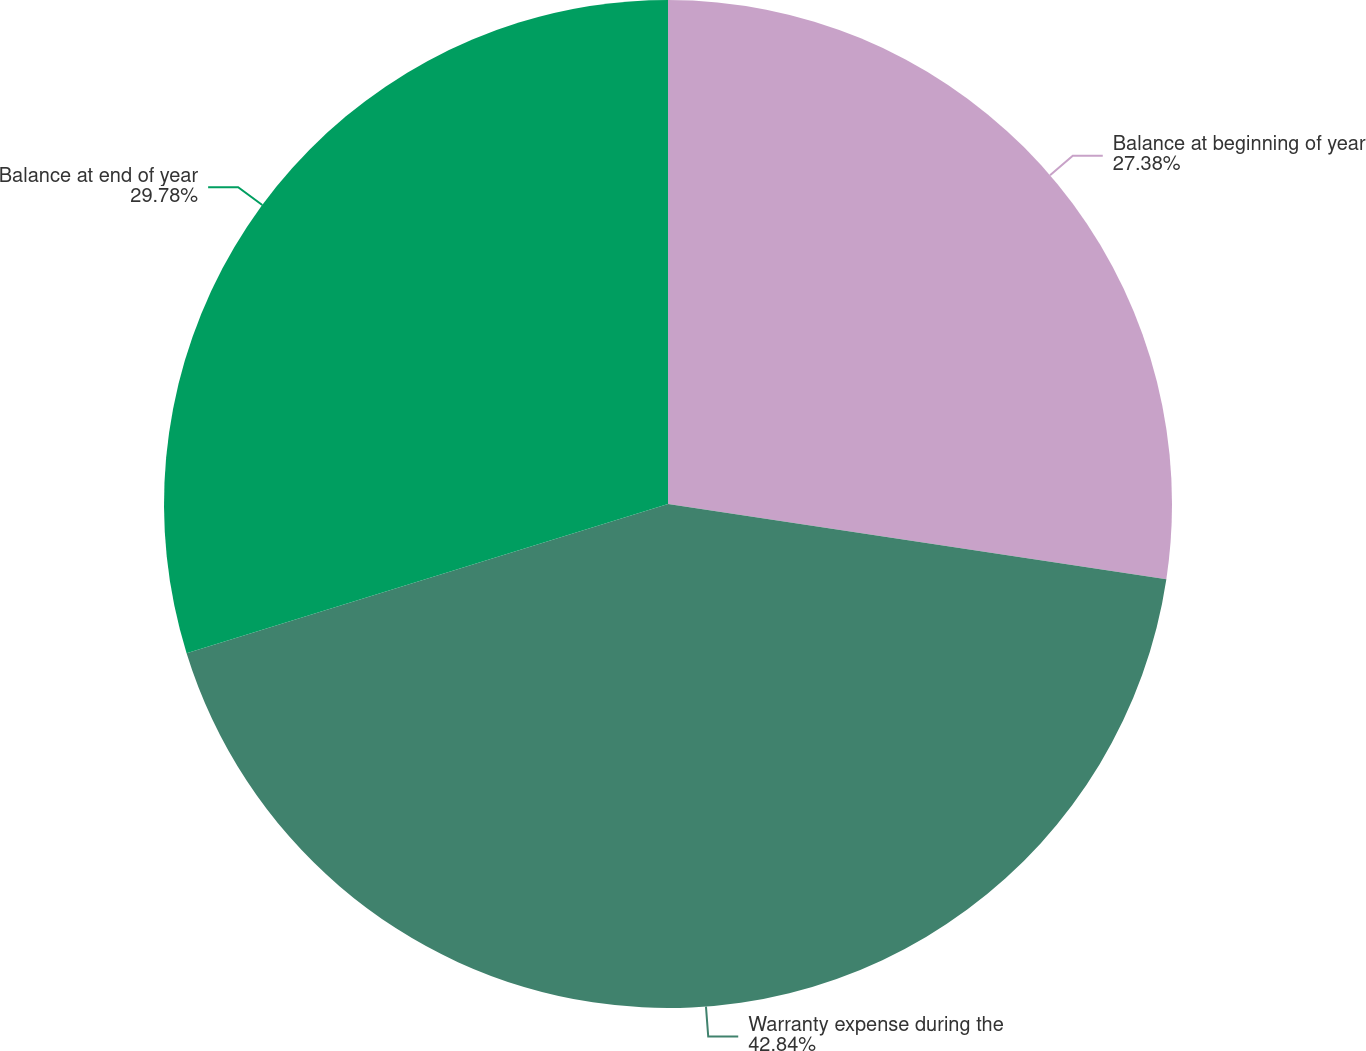Convert chart to OTSL. <chart><loc_0><loc_0><loc_500><loc_500><pie_chart><fcel>Balance at beginning of year<fcel>Warranty expense during the<fcel>Balance at end of year<nl><fcel>27.38%<fcel>42.83%<fcel>29.78%<nl></chart> 